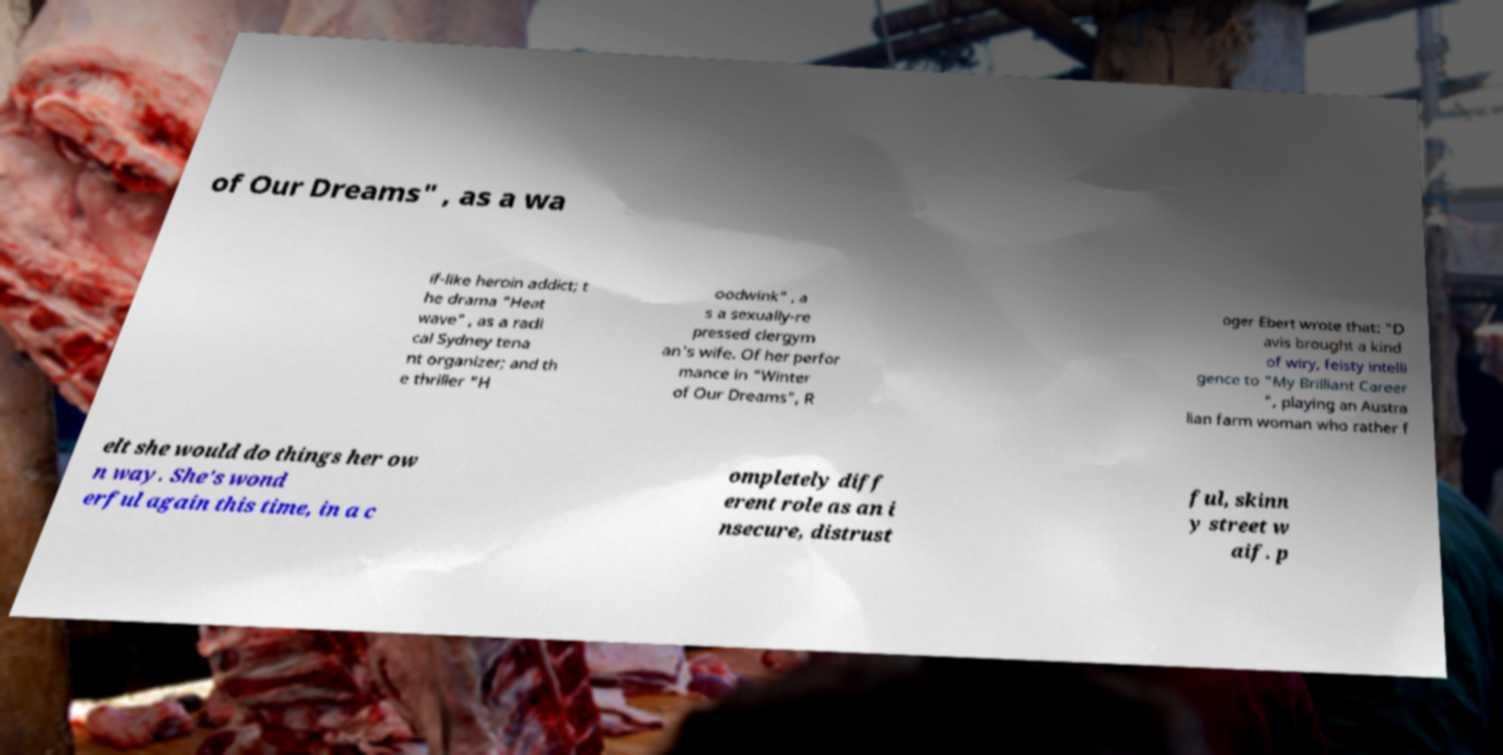Can you read and provide the text displayed in the image?This photo seems to have some interesting text. Can you extract and type it out for me? of Our Dreams" , as a wa if-like heroin addict; t he drama "Heat wave" , as a radi cal Sydney tena nt organizer; and th e thriller "H oodwink" , a s a sexually-re pressed clergym an's wife. Of her perfor mance in "Winter of Our Dreams", R oger Ebert wrote that: "D avis brought a kind of wiry, feisty intelli gence to "My Brilliant Career ", playing an Austra lian farm woman who rather f elt she would do things her ow n way. She's wond erful again this time, in a c ompletely diff erent role as an i nsecure, distrust ful, skinn y street w aif. p 